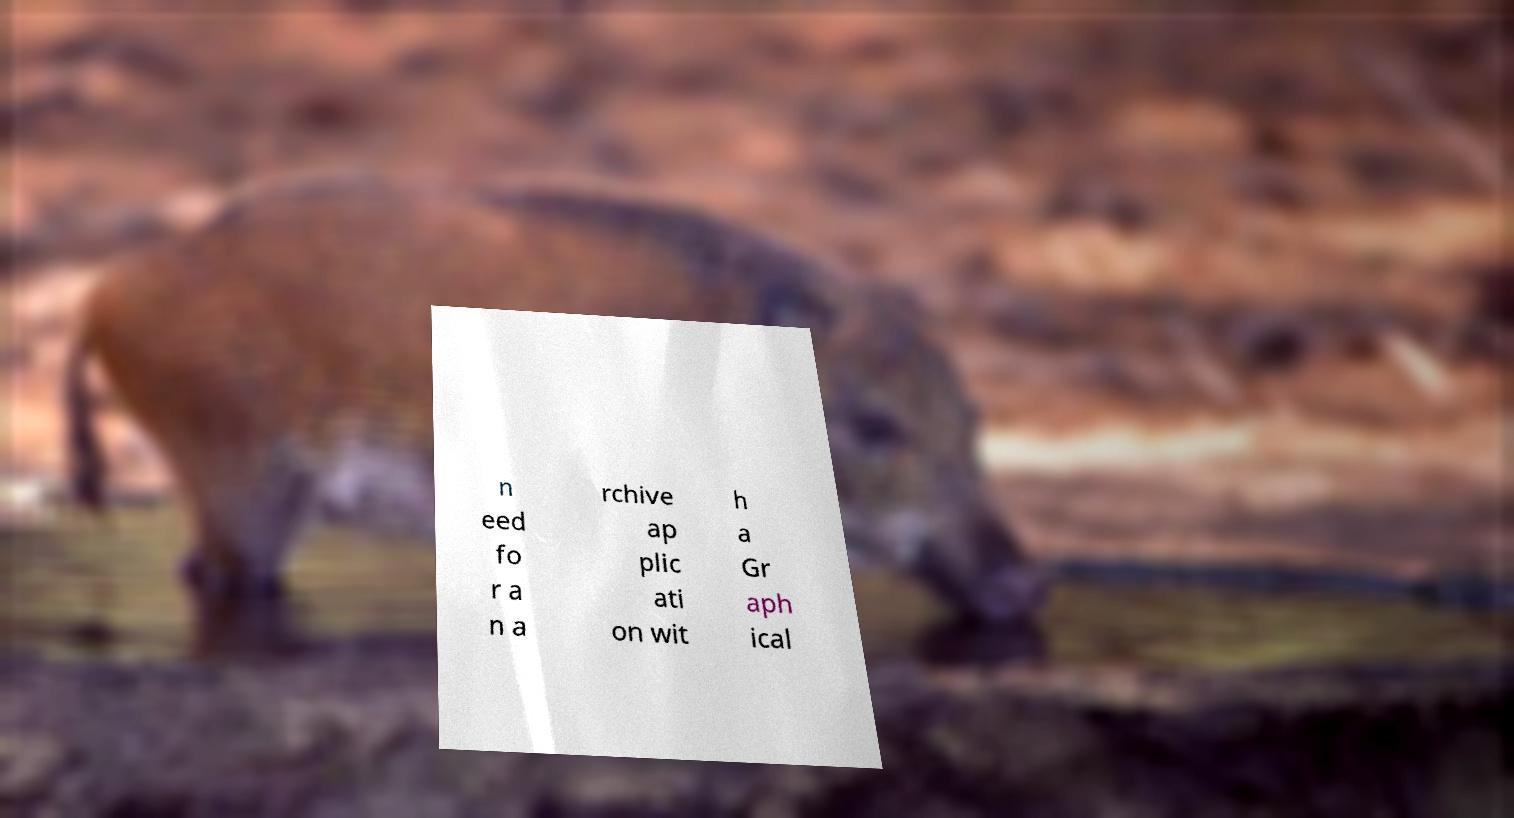Can you accurately transcribe the text from the provided image for me? n eed fo r a n a rchive ap plic ati on wit h a Gr aph ical 